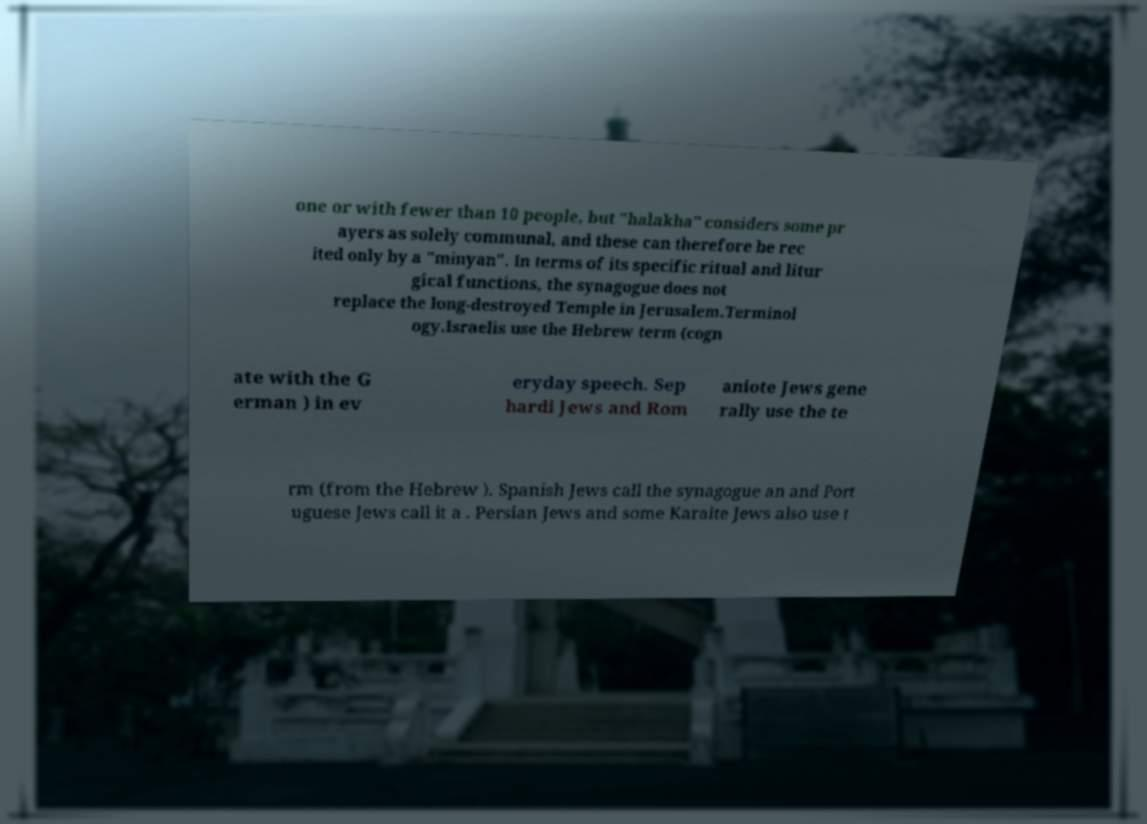I need the written content from this picture converted into text. Can you do that? one or with fewer than 10 people, but "halakha" considers some pr ayers as solely communal, and these can therefore be rec ited only by a "minyan". In terms of its specific ritual and litur gical functions, the synagogue does not replace the long-destroyed Temple in Jerusalem.Terminol ogy.Israelis use the Hebrew term (cogn ate with the G erman ) in ev eryday speech. Sep hardi Jews and Rom aniote Jews gene rally use the te rm (from the Hebrew ). Spanish Jews call the synagogue an and Port uguese Jews call it a . Persian Jews and some Karaite Jews also use t 